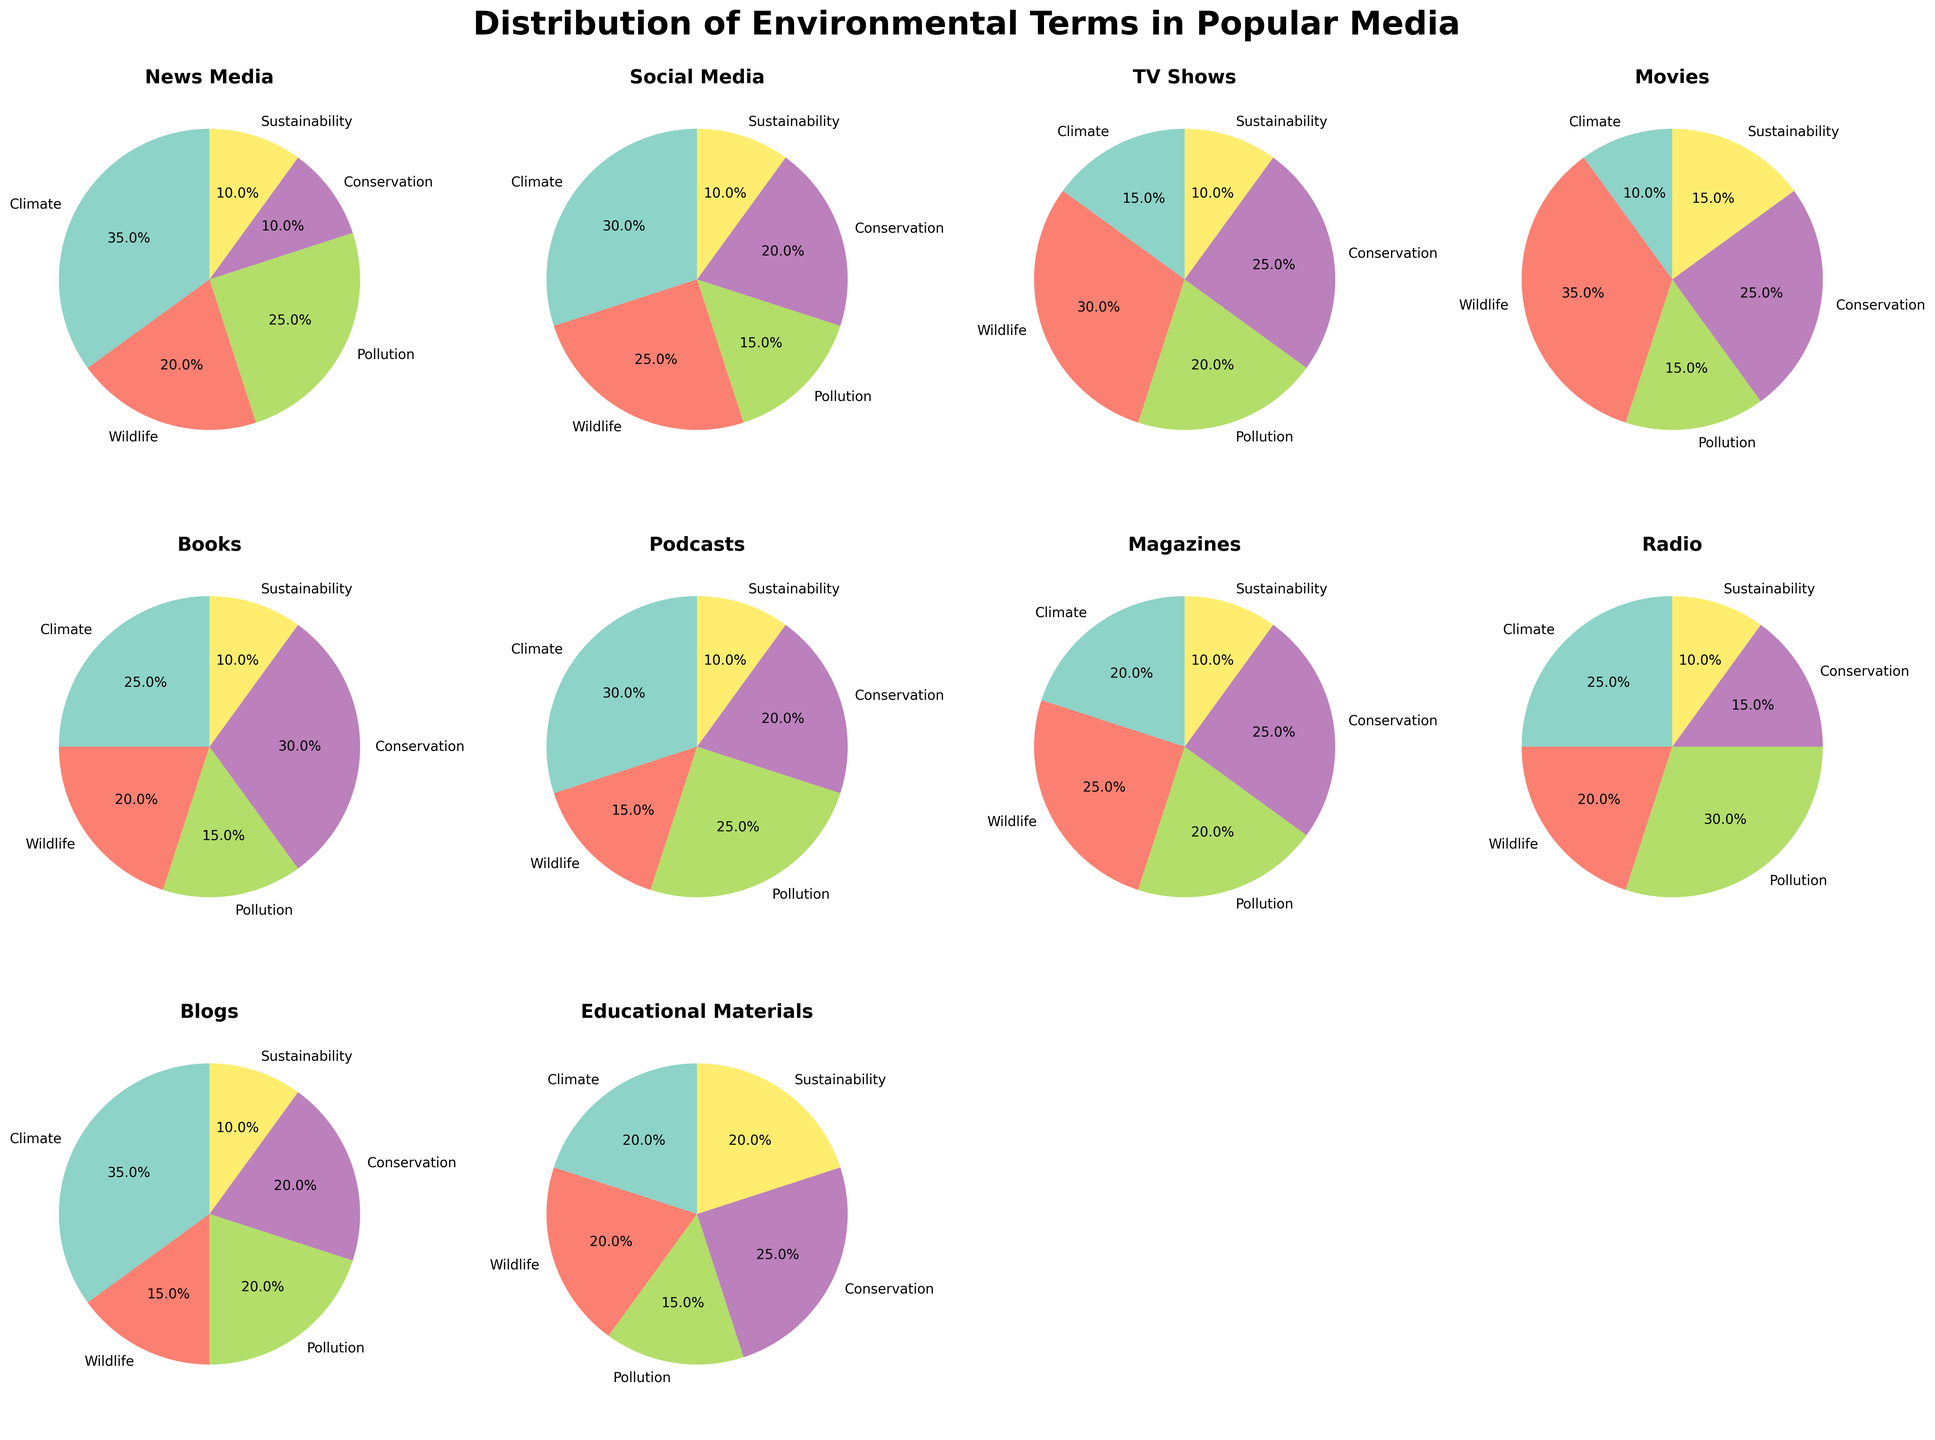What category shows the highest percentage for the term "Wildlife"? Examine each pie chart and see which category has the largest segment labeled "Wildlife". Movies have the highest percentage of Wildlife at 35%.
Answer: Movies Which category has the lowest percentage for the term "Pollution"? Look at the pie segments labeled "Pollution" in each pie chart. Social Media has the lowest percentage at 15%.
Answer: Social Media What is the total percentage for "Conservation" across all categories? Sum the percentages for "Conservation" from each pie chart: 10 + 20 + 25 + 25 + 30 + 20 + 25 + 15 + 20 + 25 = 215.
Answer: 215% Does any category have an equal distribution of terms? Check if there is any pie chart where all segments are equal. None of the categories have an equal distribution.
Answer: No Which two categories have the closest percentage for "Sustainability"? Compare the "Sustainability" segment sizes in each pie chart. News Media, Social Media, TV Shows, Magazines, Radio, Blogs all have the same percentage of 10%. Therefore, several pairs have the closest percentage for "Sustainability".
Answer: News Media and Social Media (among others) Which category has the second highest percentage of "Climate"? Arrange each category's "Climate" percentage from highest to lowest and find the second highest. Blogs has the highest at 35%, followed by News Media also at 35%, but since the question asks for a singular category with the second highest, only one must be chosen.
Answer: News Media What is the average percentage of "Climate" across all categories? Sum all "Climate" percentages and divide by the number of categories: (35 + 30 + 15 + 10 + 25 + 30 + 20 + 25 + 35 + 20) / 10 = 245 / 10 = 24.5%.
Answer: 24.5% Which categories have more than 30% for any term? Identify categories where any term exceeds 30% in their distribution pie chart. News Media (35% Climate), Movies (35% Wildlife), and Blogs (35% Climate).
Answer: News Media, Movies, Blogs What is the difference in the percentage of "Wildlife" between TV Shows and Educational Materials? Subtract the percentage of Wildlife in Educational Materials from that in TV Shows: 30% - 20% = 10%.
Answer: 10% Which term appears most frequently as the highest percentage within its category? Identify which term has the highest percentage within each category and count their occurrences. "Wildlife" appears most frequently as the highest segment.
Answer: Wildlife 